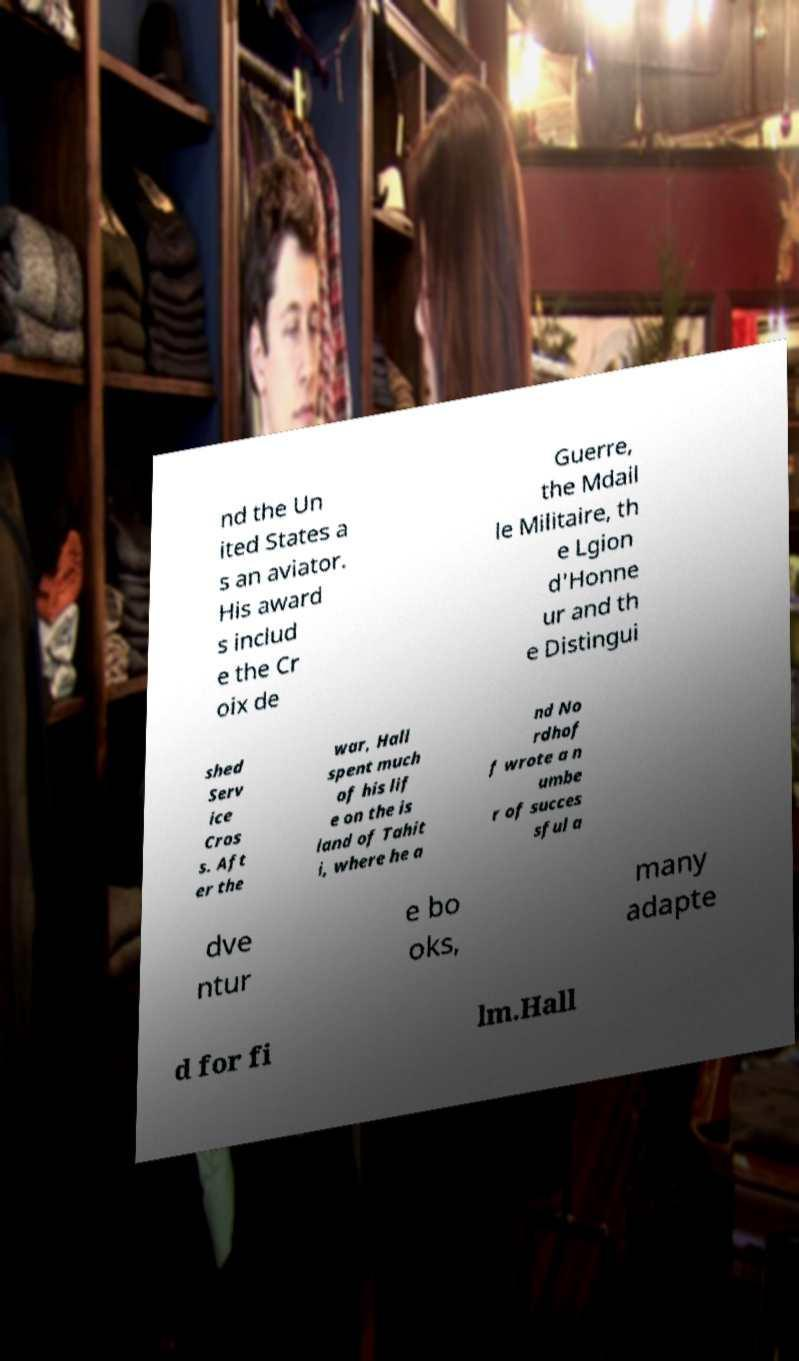Can you accurately transcribe the text from the provided image for me? nd the Un ited States a s an aviator. His award s includ e the Cr oix de Guerre, the Mdail le Militaire, th e Lgion d'Honne ur and th e Distingui shed Serv ice Cros s. Aft er the war, Hall spent much of his lif e on the is land of Tahit i, where he a nd No rdhof f wrote a n umbe r of succes sful a dve ntur e bo oks, many adapte d for fi lm.Hall 